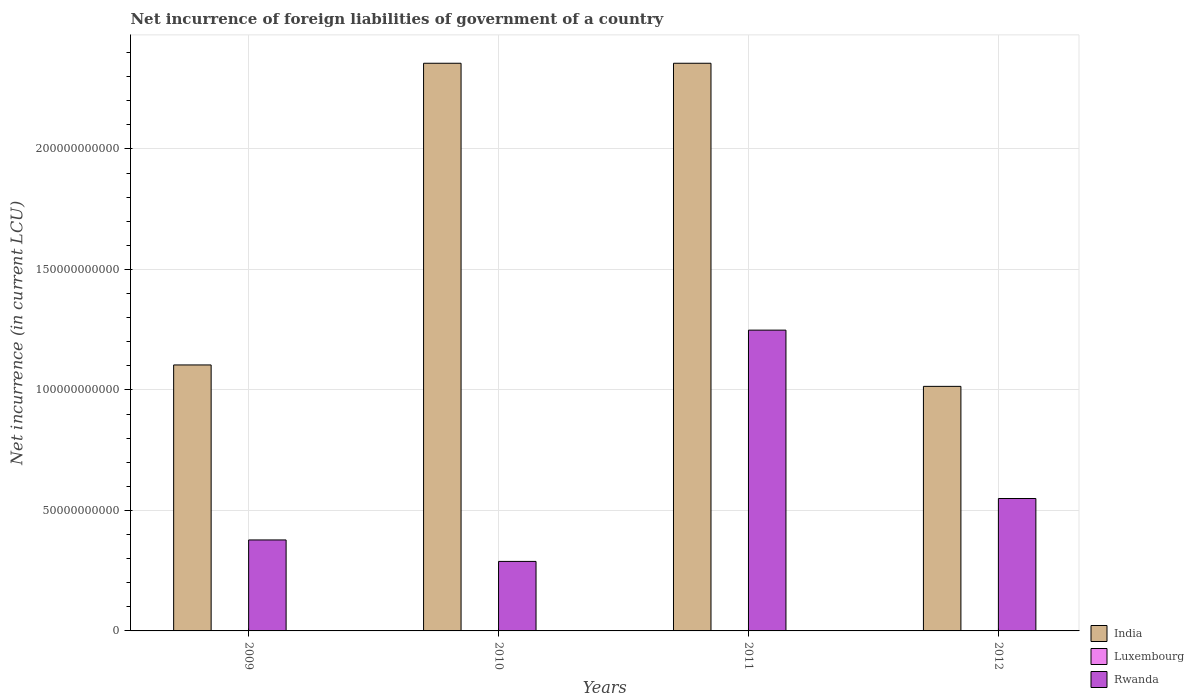How many different coloured bars are there?
Provide a succinct answer. 3. How many bars are there on the 2nd tick from the left?
Ensure brevity in your answer.  3. What is the net incurrence of foreign liabilities in Luxembourg in 2009?
Your response must be concise. 6.20e+06. Across all years, what is the maximum net incurrence of foreign liabilities in Rwanda?
Provide a succinct answer. 1.25e+11. Across all years, what is the minimum net incurrence of foreign liabilities in Rwanda?
Give a very brief answer. 2.88e+1. What is the total net incurrence of foreign liabilities in Luxembourg in the graph?
Provide a succinct answer. 1.55e+07. What is the difference between the net incurrence of foreign liabilities in India in 2010 and that in 2011?
Your answer should be compact. 0. What is the difference between the net incurrence of foreign liabilities in Luxembourg in 2011 and the net incurrence of foreign liabilities in India in 2012?
Your response must be concise. -1.01e+11. What is the average net incurrence of foreign liabilities in India per year?
Your response must be concise. 1.71e+11. In the year 2012, what is the difference between the net incurrence of foreign liabilities in India and net incurrence of foreign liabilities in Rwanda?
Offer a very short reply. 4.65e+1. In how many years, is the net incurrence of foreign liabilities in Rwanda greater than 150000000000 LCU?
Provide a short and direct response. 0. What is the ratio of the net incurrence of foreign liabilities in Rwanda in 2011 to that in 2012?
Offer a very short reply. 2.27. Is the difference between the net incurrence of foreign liabilities in India in 2010 and 2011 greater than the difference between the net incurrence of foreign liabilities in Rwanda in 2010 and 2011?
Provide a short and direct response. Yes. What is the difference between the highest and the second highest net incurrence of foreign liabilities in Rwanda?
Your answer should be very brief. 6.99e+1. What is the difference between the highest and the lowest net incurrence of foreign liabilities in Rwanda?
Offer a very short reply. 9.60e+1. What does the 2nd bar from the left in 2009 represents?
Keep it short and to the point. Luxembourg. What does the 1st bar from the right in 2009 represents?
Ensure brevity in your answer.  Rwanda. How many bars are there?
Make the answer very short. 12. Are all the bars in the graph horizontal?
Provide a succinct answer. No. What is the difference between two consecutive major ticks on the Y-axis?
Keep it short and to the point. 5.00e+1. Where does the legend appear in the graph?
Give a very brief answer. Bottom right. How are the legend labels stacked?
Offer a very short reply. Vertical. What is the title of the graph?
Offer a terse response. Net incurrence of foreign liabilities of government of a country. Does "South Asia" appear as one of the legend labels in the graph?
Provide a succinct answer. No. What is the label or title of the Y-axis?
Provide a succinct answer. Net incurrence (in current LCU). What is the Net incurrence (in current LCU) in India in 2009?
Keep it short and to the point. 1.10e+11. What is the Net incurrence (in current LCU) of Luxembourg in 2009?
Your response must be concise. 6.20e+06. What is the Net incurrence (in current LCU) of Rwanda in 2009?
Keep it short and to the point. 3.78e+1. What is the Net incurrence (in current LCU) in India in 2010?
Ensure brevity in your answer.  2.36e+11. What is the Net incurrence (in current LCU) in Rwanda in 2010?
Keep it short and to the point. 2.88e+1. What is the Net incurrence (in current LCU) of India in 2011?
Your response must be concise. 2.36e+11. What is the Net incurrence (in current LCU) in Luxembourg in 2011?
Your response must be concise. 3.16e+06. What is the Net incurrence (in current LCU) of Rwanda in 2011?
Provide a succinct answer. 1.25e+11. What is the Net incurrence (in current LCU) in India in 2012?
Offer a very short reply. 1.01e+11. What is the Net incurrence (in current LCU) of Luxembourg in 2012?
Give a very brief answer. 3.16e+06. What is the Net incurrence (in current LCU) of Rwanda in 2012?
Your response must be concise. 5.49e+1. Across all years, what is the maximum Net incurrence (in current LCU) of India?
Make the answer very short. 2.36e+11. Across all years, what is the maximum Net incurrence (in current LCU) in Luxembourg?
Give a very brief answer. 6.20e+06. Across all years, what is the maximum Net incurrence (in current LCU) in Rwanda?
Ensure brevity in your answer.  1.25e+11. Across all years, what is the minimum Net incurrence (in current LCU) in India?
Your response must be concise. 1.01e+11. Across all years, what is the minimum Net incurrence (in current LCU) of Rwanda?
Your answer should be very brief. 2.88e+1. What is the total Net incurrence (in current LCU) of India in the graph?
Give a very brief answer. 6.83e+11. What is the total Net incurrence (in current LCU) in Luxembourg in the graph?
Offer a very short reply. 1.55e+07. What is the total Net incurrence (in current LCU) in Rwanda in the graph?
Provide a short and direct response. 2.46e+11. What is the difference between the Net incurrence (in current LCU) in India in 2009 and that in 2010?
Provide a succinct answer. -1.25e+11. What is the difference between the Net incurrence (in current LCU) of Luxembourg in 2009 and that in 2010?
Make the answer very short. 3.20e+06. What is the difference between the Net incurrence (in current LCU) of Rwanda in 2009 and that in 2010?
Give a very brief answer. 8.91e+09. What is the difference between the Net incurrence (in current LCU) in India in 2009 and that in 2011?
Provide a short and direct response. -1.25e+11. What is the difference between the Net incurrence (in current LCU) of Luxembourg in 2009 and that in 2011?
Ensure brevity in your answer.  3.04e+06. What is the difference between the Net incurrence (in current LCU) of Rwanda in 2009 and that in 2011?
Provide a succinct answer. -8.71e+1. What is the difference between the Net incurrence (in current LCU) in India in 2009 and that in 2012?
Keep it short and to the point. 8.89e+09. What is the difference between the Net incurrence (in current LCU) in Luxembourg in 2009 and that in 2012?
Your answer should be compact. 3.04e+06. What is the difference between the Net incurrence (in current LCU) of Rwanda in 2009 and that in 2012?
Your answer should be very brief. -1.72e+1. What is the difference between the Net incurrence (in current LCU) of India in 2010 and that in 2011?
Make the answer very short. 0. What is the difference between the Net incurrence (in current LCU) in Luxembourg in 2010 and that in 2011?
Provide a succinct answer. -1.57e+05. What is the difference between the Net incurrence (in current LCU) in Rwanda in 2010 and that in 2011?
Ensure brevity in your answer.  -9.60e+1. What is the difference between the Net incurrence (in current LCU) of India in 2010 and that in 2012?
Give a very brief answer. 1.34e+11. What is the difference between the Net incurrence (in current LCU) of Luxembourg in 2010 and that in 2012?
Your answer should be compact. -1.57e+05. What is the difference between the Net incurrence (in current LCU) in Rwanda in 2010 and that in 2012?
Provide a succinct answer. -2.61e+1. What is the difference between the Net incurrence (in current LCU) in India in 2011 and that in 2012?
Give a very brief answer. 1.34e+11. What is the difference between the Net incurrence (in current LCU) in Luxembourg in 2011 and that in 2012?
Your answer should be very brief. 0. What is the difference between the Net incurrence (in current LCU) in Rwanda in 2011 and that in 2012?
Offer a terse response. 6.99e+1. What is the difference between the Net incurrence (in current LCU) in India in 2009 and the Net incurrence (in current LCU) in Luxembourg in 2010?
Provide a succinct answer. 1.10e+11. What is the difference between the Net incurrence (in current LCU) of India in 2009 and the Net incurrence (in current LCU) of Rwanda in 2010?
Your answer should be compact. 8.15e+1. What is the difference between the Net incurrence (in current LCU) in Luxembourg in 2009 and the Net incurrence (in current LCU) in Rwanda in 2010?
Provide a short and direct response. -2.88e+1. What is the difference between the Net incurrence (in current LCU) in India in 2009 and the Net incurrence (in current LCU) in Luxembourg in 2011?
Make the answer very short. 1.10e+11. What is the difference between the Net incurrence (in current LCU) in India in 2009 and the Net incurrence (in current LCU) in Rwanda in 2011?
Your response must be concise. -1.44e+1. What is the difference between the Net incurrence (in current LCU) of Luxembourg in 2009 and the Net incurrence (in current LCU) of Rwanda in 2011?
Provide a short and direct response. -1.25e+11. What is the difference between the Net incurrence (in current LCU) of India in 2009 and the Net incurrence (in current LCU) of Luxembourg in 2012?
Your answer should be very brief. 1.10e+11. What is the difference between the Net incurrence (in current LCU) of India in 2009 and the Net incurrence (in current LCU) of Rwanda in 2012?
Provide a succinct answer. 5.54e+1. What is the difference between the Net incurrence (in current LCU) of Luxembourg in 2009 and the Net incurrence (in current LCU) of Rwanda in 2012?
Provide a succinct answer. -5.49e+1. What is the difference between the Net incurrence (in current LCU) in India in 2010 and the Net incurrence (in current LCU) in Luxembourg in 2011?
Your answer should be compact. 2.36e+11. What is the difference between the Net incurrence (in current LCU) in India in 2010 and the Net incurrence (in current LCU) in Rwanda in 2011?
Provide a short and direct response. 1.11e+11. What is the difference between the Net incurrence (in current LCU) in Luxembourg in 2010 and the Net incurrence (in current LCU) in Rwanda in 2011?
Provide a succinct answer. -1.25e+11. What is the difference between the Net incurrence (in current LCU) of India in 2010 and the Net incurrence (in current LCU) of Luxembourg in 2012?
Ensure brevity in your answer.  2.36e+11. What is the difference between the Net incurrence (in current LCU) of India in 2010 and the Net incurrence (in current LCU) of Rwanda in 2012?
Your answer should be compact. 1.81e+11. What is the difference between the Net incurrence (in current LCU) of Luxembourg in 2010 and the Net incurrence (in current LCU) of Rwanda in 2012?
Provide a succinct answer. -5.49e+1. What is the difference between the Net incurrence (in current LCU) in India in 2011 and the Net incurrence (in current LCU) in Luxembourg in 2012?
Make the answer very short. 2.36e+11. What is the difference between the Net incurrence (in current LCU) in India in 2011 and the Net incurrence (in current LCU) in Rwanda in 2012?
Your answer should be very brief. 1.81e+11. What is the difference between the Net incurrence (in current LCU) in Luxembourg in 2011 and the Net incurrence (in current LCU) in Rwanda in 2012?
Make the answer very short. -5.49e+1. What is the average Net incurrence (in current LCU) in India per year?
Keep it short and to the point. 1.71e+11. What is the average Net incurrence (in current LCU) of Luxembourg per year?
Your answer should be very brief. 3.88e+06. What is the average Net incurrence (in current LCU) in Rwanda per year?
Provide a short and direct response. 6.16e+1. In the year 2009, what is the difference between the Net incurrence (in current LCU) of India and Net incurrence (in current LCU) of Luxembourg?
Ensure brevity in your answer.  1.10e+11. In the year 2009, what is the difference between the Net incurrence (in current LCU) of India and Net incurrence (in current LCU) of Rwanda?
Provide a succinct answer. 7.26e+1. In the year 2009, what is the difference between the Net incurrence (in current LCU) in Luxembourg and Net incurrence (in current LCU) in Rwanda?
Offer a terse response. -3.77e+1. In the year 2010, what is the difference between the Net incurrence (in current LCU) in India and Net incurrence (in current LCU) in Luxembourg?
Ensure brevity in your answer.  2.36e+11. In the year 2010, what is the difference between the Net incurrence (in current LCU) of India and Net incurrence (in current LCU) of Rwanda?
Provide a succinct answer. 2.07e+11. In the year 2010, what is the difference between the Net incurrence (in current LCU) of Luxembourg and Net incurrence (in current LCU) of Rwanda?
Give a very brief answer. -2.88e+1. In the year 2011, what is the difference between the Net incurrence (in current LCU) of India and Net incurrence (in current LCU) of Luxembourg?
Give a very brief answer. 2.36e+11. In the year 2011, what is the difference between the Net incurrence (in current LCU) of India and Net incurrence (in current LCU) of Rwanda?
Offer a very short reply. 1.11e+11. In the year 2011, what is the difference between the Net incurrence (in current LCU) in Luxembourg and Net incurrence (in current LCU) in Rwanda?
Ensure brevity in your answer.  -1.25e+11. In the year 2012, what is the difference between the Net incurrence (in current LCU) in India and Net incurrence (in current LCU) in Luxembourg?
Provide a short and direct response. 1.01e+11. In the year 2012, what is the difference between the Net incurrence (in current LCU) of India and Net incurrence (in current LCU) of Rwanda?
Your response must be concise. 4.65e+1. In the year 2012, what is the difference between the Net incurrence (in current LCU) in Luxembourg and Net incurrence (in current LCU) in Rwanda?
Offer a terse response. -5.49e+1. What is the ratio of the Net incurrence (in current LCU) in India in 2009 to that in 2010?
Provide a succinct answer. 0.47. What is the ratio of the Net incurrence (in current LCU) of Luxembourg in 2009 to that in 2010?
Your response must be concise. 2.07. What is the ratio of the Net incurrence (in current LCU) of Rwanda in 2009 to that in 2010?
Offer a very short reply. 1.31. What is the ratio of the Net incurrence (in current LCU) of India in 2009 to that in 2011?
Your answer should be very brief. 0.47. What is the ratio of the Net incurrence (in current LCU) of Luxembourg in 2009 to that in 2011?
Keep it short and to the point. 1.96. What is the ratio of the Net incurrence (in current LCU) of Rwanda in 2009 to that in 2011?
Your response must be concise. 0.3. What is the ratio of the Net incurrence (in current LCU) in India in 2009 to that in 2012?
Give a very brief answer. 1.09. What is the ratio of the Net incurrence (in current LCU) of Luxembourg in 2009 to that in 2012?
Provide a succinct answer. 1.96. What is the ratio of the Net incurrence (in current LCU) in Rwanda in 2009 to that in 2012?
Offer a terse response. 0.69. What is the ratio of the Net incurrence (in current LCU) in Luxembourg in 2010 to that in 2011?
Offer a terse response. 0.95. What is the ratio of the Net incurrence (in current LCU) of Rwanda in 2010 to that in 2011?
Your response must be concise. 0.23. What is the ratio of the Net incurrence (in current LCU) of India in 2010 to that in 2012?
Keep it short and to the point. 2.32. What is the ratio of the Net incurrence (in current LCU) of Luxembourg in 2010 to that in 2012?
Your answer should be very brief. 0.95. What is the ratio of the Net incurrence (in current LCU) of Rwanda in 2010 to that in 2012?
Make the answer very short. 0.52. What is the ratio of the Net incurrence (in current LCU) of India in 2011 to that in 2012?
Offer a very short reply. 2.32. What is the ratio of the Net incurrence (in current LCU) in Rwanda in 2011 to that in 2012?
Provide a succinct answer. 2.27. What is the difference between the highest and the second highest Net incurrence (in current LCU) in India?
Make the answer very short. 0. What is the difference between the highest and the second highest Net incurrence (in current LCU) of Luxembourg?
Provide a succinct answer. 3.04e+06. What is the difference between the highest and the second highest Net incurrence (in current LCU) of Rwanda?
Provide a succinct answer. 6.99e+1. What is the difference between the highest and the lowest Net incurrence (in current LCU) of India?
Your answer should be very brief. 1.34e+11. What is the difference between the highest and the lowest Net incurrence (in current LCU) of Luxembourg?
Keep it short and to the point. 3.20e+06. What is the difference between the highest and the lowest Net incurrence (in current LCU) in Rwanda?
Ensure brevity in your answer.  9.60e+1. 